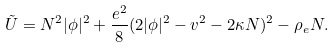Convert formula to latex. <formula><loc_0><loc_0><loc_500><loc_500>\tilde { U } = N ^ { 2 } | \phi | ^ { 2 } + \frac { e ^ { 2 } } { 8 } ( 2 | \phi | ^ { 2 } - v ^ { 2 } - 2 \kappa N ) ^ { 2 } - \rho _ { e } N .</formula> 